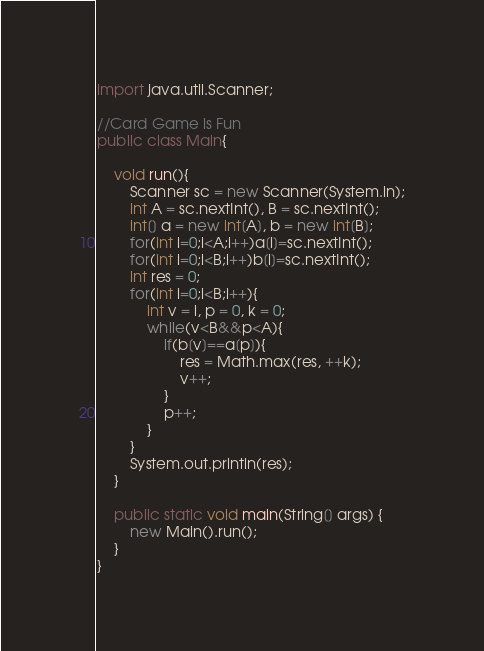<code> <loc_0><loc_0><loc_500><loc_500><_Java_>import java.util.Scanner;

//Card Game is Fun
public class Main{

	void run(){
		Scanner sc = new Scanner(System.in);
		int A = sc.nextInt(), B = sc.nextInt();
		int[] a = new int[A], b = new int[B];
		for(int i=0;i<A;i++)a[i]=sc.nextInt();
		for(int i=0;i<B;i++)b[i]=sc.nextInt();
		int res = 0;
		for(int i=0;i<B;i++){
			int v = i, p = 0, k = 0;
			while(v<B&&p<A){
				if(b[v]==a[p]){
					res = Math.max(res, ++k);
					v++;
				}
				p++;
			}
		}
		System.out.println(res);
	}
	
	public static void main(String[] args) {
		new Main().run();
	}
}</code> 